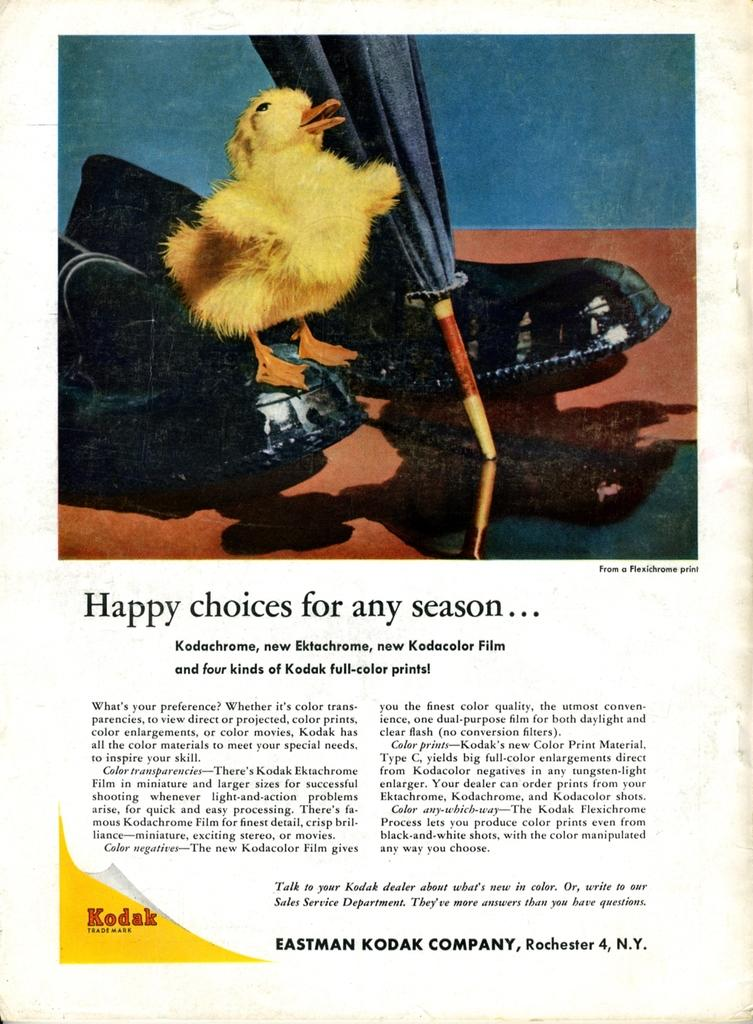What is featured on the poster in the image? There is a poster in the image, and it features a duck. Can you describe the duck on the poster? The duck on the poster is yellow in color. What else is on the poster besides the duck? There is a closed umbrella on the poster. What can be found at the bottom of the poster? There is some matter written at the bottom of the poster. What type of birthday cake is being served at the edge of the image? There is no birthday cake or edge present in the image; it only features a poster with a duck, a closed umbrella, and some written matter. 